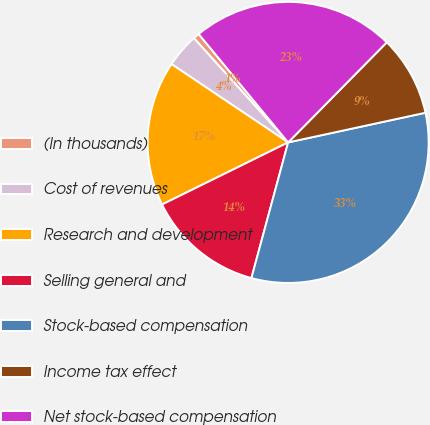Convert chart. <chart><loc_0><loc_0><loc_500><loc_500><pie_chart><fcel>(In thousands)<fcel>Cost of revenues<fcel>Research and development<fcel>Selling general and<fcel>Stock-based compensation<fcel>Income tax effect<fcel>Net stock-based compensation<nl><fcel>0.71%<fcel>3.9%<fcel>16.7%<fcel>13.51%<fcel>32.6%<fcel>9.23%<fcel>23.37%<nl></chart> 